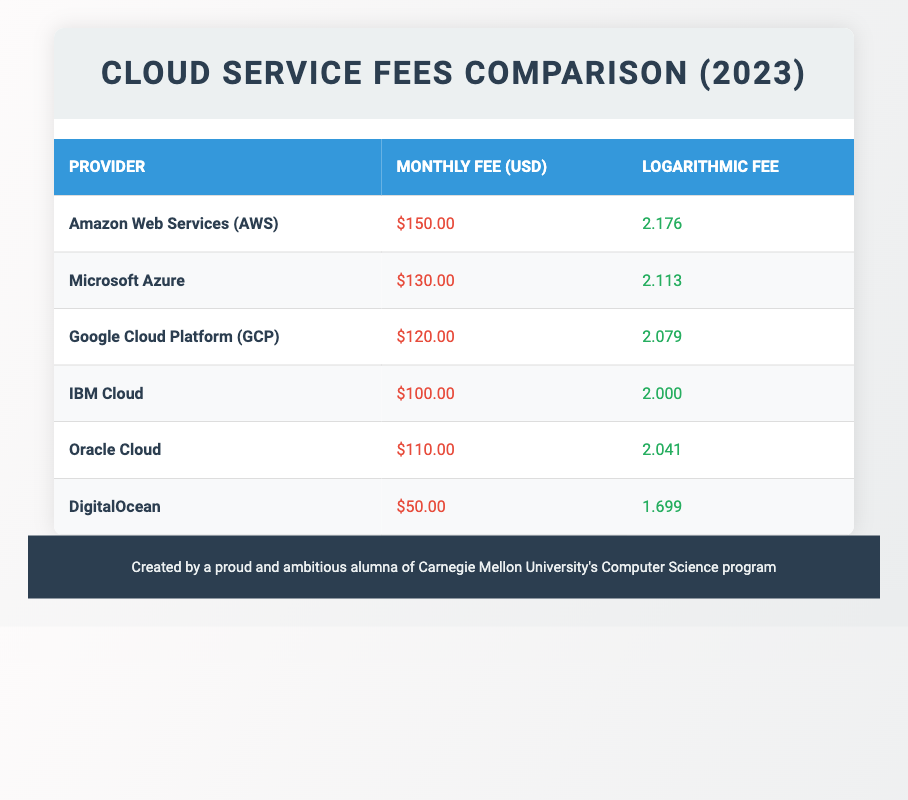What is the monthly fee for Google Cloud Platform? The monthly fee for Google Cloud Platform can be found in the table under the "Monthly Fee (USD)" column for the row labeled "Google Cloud Platform (GCP)", which states it is $120.00.
Answer: $120.00 Which provider has the highest monthly fee? To find the provider with the highest monthly fee, we review all the fees in the "Monthly Fee (USD)" column. The highest value is $150.00 for Amazon Web Services (AWS).
Answer: Amazon Web Services (AWS) Is the logarithmic fee for Microsoft Azure greater than that for IBM Cloud? We need to compare the values in the "Logarithmic Fee" column for Microsoft Azure and IBM Cloud. Microsoft Azure has a logarithmic fee of 2.113, while IBM Cloud has a logarithmic fee of 2.000. Since 2.113 is greater than 2.000, the statement is true.
Answer: Yes What is the average monthly fee across all providers? To calculate the average monthly fee, we sum the monthly fees of all providers: $150.00 + $130.00 + $120.00 + $100.00 + $110.00 + $50.00 = $660.00. There are 6 providers, so the average is $660.00 / 6 = $110.00.
Answer: $110.00 Which provider has a logarithmic fee less than 2.1, and what is that value? Checking the "Logarithmic Fee" column, we find that DigitalOcean has a logarithmic fee of 1.699, which is less than 2.1. No other providers fall into this category.
Answer: DigitalOcean, 1.699 